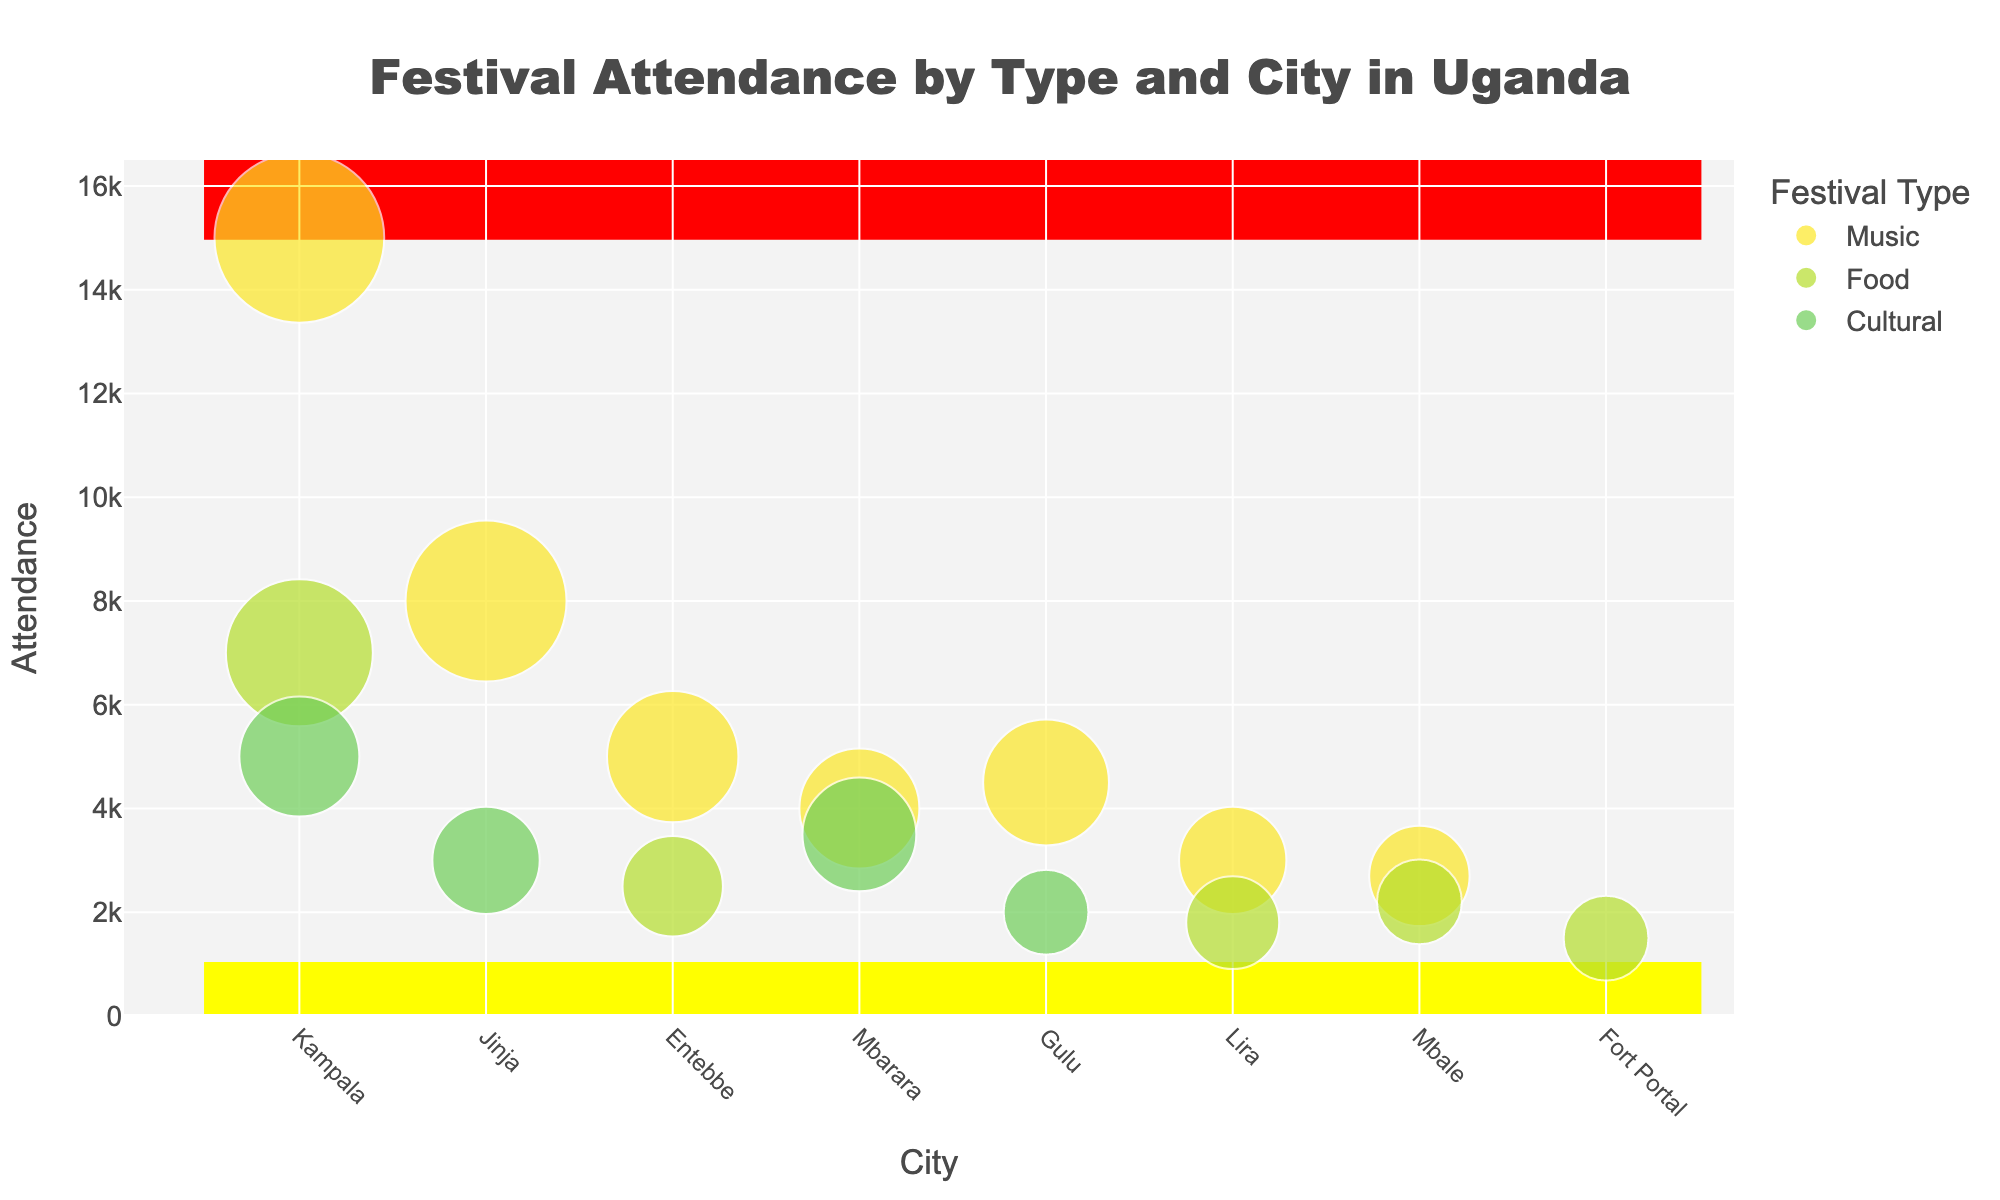What city has the highest attendance for music festivals? Look for the bubbles labeled "Music" and compare their positions along the y-axis labeled "Attendance". The highest point indicates the highest attendance. Kampala's bubble is the highest.
Answer: Kampala Which city has the lowest attendance for food festivals? Find the bubbles labeled "Food" on the y-axis. Compare their heights to find the lowest point. Fort Portal's bubble is the lowest.
Answer: Fort Portal What's the average attendance for cultural festivals? Locate all bubbles labeled "Cultural" and note their attendance values: 5000 (Kampala), 3000 (Jinja), 3500 (Mbarara), 2000 (Gulu). Calculate the average: (5000 + 3000 + 3500 + 2000) / 4 = 13500 / 4 = 3375.
Answer: 3375 Which city has the largest bubble for food festivals? Look for the bubbles labeled "Food" and compare their sizes. Kampala has the largest bubble.
Answer: Kampala Compare the attendance of cultural festivals in Mbarara and Gulu. Which is larger? Identify the bubbles for "Cultural" in Mbarara and Gulu, and compare their heights. Mbarara's bubble is higher than Gulu's.
Answer: Mbarara Calculate the total attendance for music festivals in Kampala, Jinja, and Entebbe. Sum the attendance values for music festivals in these cities: 15000 (Kampala), 8000 (Jinja), 5000 (Entebbe). The total is 15000 + 8000 + 5000 = 28000.
Answer: 28000 How does the attendance of music festivals in Gulu compare to Lira? Locate the bubbles for "Music" in both cities and compare their heights. Gulu's attendance (4500) is higher than Lira's (3000).
Answer: Gulu Which city has equal attendance for music and food festivals? Find a city where the heights of "Music" and "Food" bubbles are the same. This occurs in none of the cities.
Answer: None Among the cities Jinja, Entebbe, and Mbale, which has the highest attendance for any festival type? Compare the highest bubbles for all festival types in Jinja (8000 for Music), Entebbe (5000 for Music), and Mbale (2700 for Music). Jinja's highest attendance is 8000.
Answer: Jinja How many cities have an attendance of fewer than 3000 people for all festival types? Count the cities where all bubbles have lower than 3000 attendance. Fort Portal, Lira, and Mbale fit this criterion.
Answer: 3 